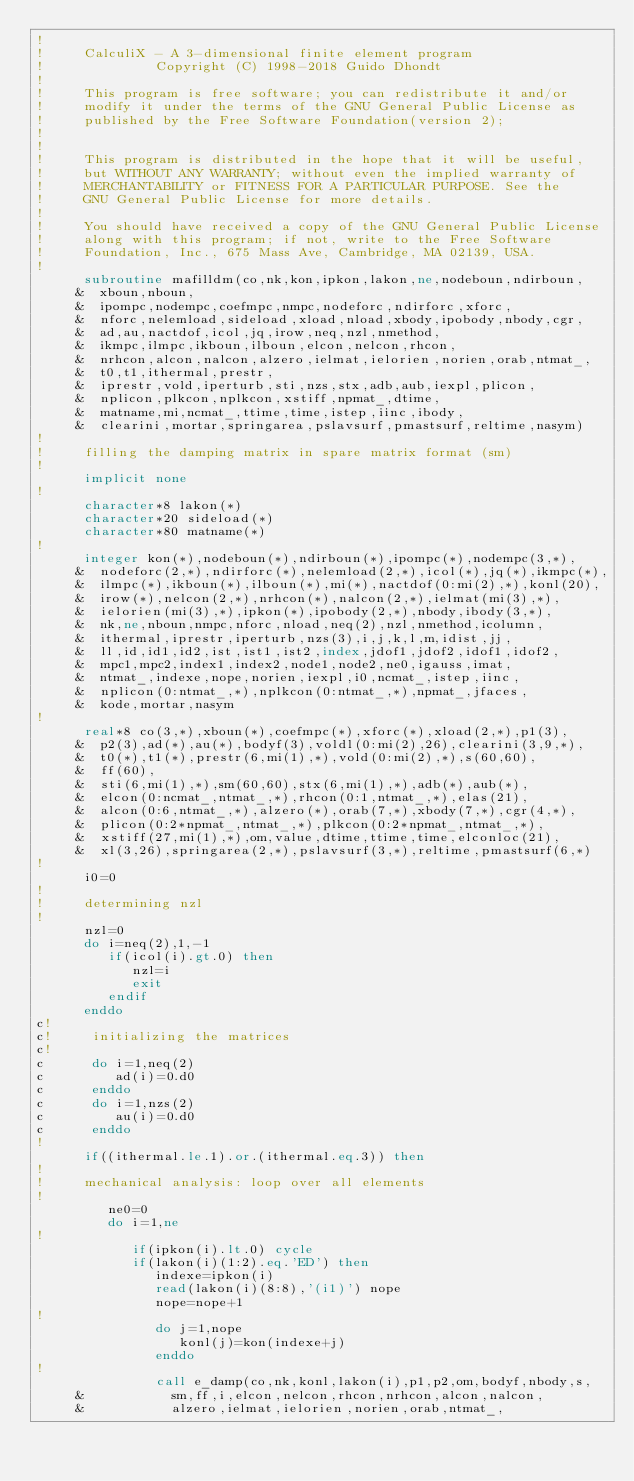<code> <loc_0><loc_0><loc_500><loc_500><_FORTRAN_>!
!     CalculiX - A 3-dimensional finite element program
!              Copyright (C) 1998-2018 Guido Dhondt
!
!     This program is free software; you can redistribute it and/or
!     modify it under the terms of the GNU General Public License as
!     published by the Free Software Foundation(version 2);
!     
!
!     This program is distributed in the hope that it will be useful,
!     but WITHOUT ANY WARRANTY; without even the implied warranty of 
!     MERCHANTABILITY or FITNESS FOR A PARTICULAR PURPOSE. See the 
!     GNU General Public License for more details.
!
!     You should have received a copy of the GNU General Public License
!     along with this program; if not, write to the Free Software
!     Foundation, Inc., 675 Mass Ave, Cambridge, MA 02139, USA.
!
      subroutine mafilldm(co,nk,kon,ipkon,lakon,ne,nodeboun,ndirboun,
     &  xboun,nboun,
     &  ipompc,nodempc,coefmpc,nmpc,nodeforc,ndirforc,xforc,
     &  nforc,nelemload,sideload,xload,nload,xbody,ipobody,nbody,cgr,
     &  ad,au,nactdof,icol,jq,irow,neq,nzl,nmethod,
     &  ikmpc,ilmpc,ikboun,ilboun,elcon,nelcon,rhcon,
     &  nrhcon,alcon,nalcon,alzero,ielmat,ielorien,norien,orab,ntmat_,
     &  t0,t1,ithermal,prestr,
     &  iprestr,vold,iperturb,sti,nzs,stx,adb,aub,iexpl,plicon,
     &  nplicon,plkcon,nplkcon,xstiff,npmat_,dtime,
     &  matname,mi,ncmat_,ttime,time,istep,iinc,ibody,
     &  clearini,mortar,springarea,pslavsurf,pmastsurf,reltime,nasym)
!
!     filling the damping matrix in spare matrix format (sm)
!
      implicit none
!
      character*8 lakon(*)
      character*20 sideload(*)
      character*80 matname(*)
!
      integer kon(*),nodeboun(*),ndirboun(*),ipompc(*),nodempc(3,*),
     &  nodeforc(2,*),ndirforc(*),nelemload(2,*),icol(*),jq(*),ikmpc(*),
     &  ilmpc(*),ikboun(*),ilboun(*),mi(*),nactdof(0:mi(2),*),konl(20),
     &  irow(*),nelcon(2,*),nrhcon(*),nalcon(2,*),ielmat(mi(3),*),
     &  ielorien(mi(3),*),ipkon(*),ipobody(2,*),nbody,ibody(3,*),
     &  nk,ne,nboun,nmpc,nforc,nload,neq(2),nzl,nmethod,icolumn,
     &  ithermal,iprestr,iperturb,nzs(3),i,j,k,l,m,idist,jj,
     &  ll,id,id1,id2,ist,ist1,ist2,index,jdof1,jdof2,idof1,idof2,
     &  mpc1,mpc2,index1,index2,node1,node2,ne0,igauss,imat,
     &  ntmat_,indexe,nope,norien,iexpl,i0,ncmat_,istep,iinc,
     &  nplicon(0:ntmat_,*),nplkcon(0:ntmat_,*),npmat_,jfaces,
     &  kode,mortar,nasym
!
      real*8 co(3,*),xboun(*),coefmpc(*),xforc(*),xload(2,*),p1(3),
     &  p2(3),ad(*),au(*),bodyf(3),voldl(0:mi(2),26),clearini(3,9,*),
     &  t0(*),t1(*),prestr(6,mi(1),*),vold(0:mi(2),*),s(60,60),
     &  ff(60),
     &  sti(6,mi(1),*),sm(60,60),stx(6,mi(1),*),adb(*),aub(*),
     &  elcon(0:ncmat_,ntmat_,*),rhcon(0:1,ntmat_,*),elas(21),
     &  alcon(0:6,ntmat_,*),alzero(*),orab(7,*),xbody(7,*),cgr(4,*),
     &  plicon(0:2*npmat_,ntmat_,*),plkcon(0:2*npmat_,ntmat_,*),
     &  xstiff(27,mi(1),*),om,value,dtime,ttime,time,elconloc(21),
     &  xl(3,26),springarea(2,*),pslavsurf(3,*),reltime,pmastsurf(6,*)
!
      i0=0
!
!     determining nzl
!
      nzl=0
      do i=neq(2),1,-1
         if(icol(i).gt.0) then
            nzl=i
            exit
         endif
      enddo
c!
c!     initializing the matrices
c!
c      do i=1,neq(2)
c         ad(i)=0.d0
c      enddo
c      do i=1,nzs(2)
c         au(i)=0.d0
c      enddo
!
      if((ithermal.le.1).or.(ithermal.eq.3)) then
!     
!     mechanical analysis: loop over all elements
!     
         ne0=0
         do i=1,ne
!     
            if(ipkon(i).lt.0) cycle
            if(lakon(i)(1:2).eq.'ED') then
               indexe=ipkon(i)
               read(lakon(i)(8:8),'(i1)') nope
               nope=nope+1
!     
               do j=1,nope
                  konl(j)=kon(indexe+j) 
               enddo
!     
               call e_damp(co,nk,konl,lakon(i),p1,p2,om,bodyf,nbody,s,
     &           sm,ff,i,elcon,nelcon,rhcon,nrhcon,alcon,nalcon,
     &           alzero,ielmat,ielorien,norien,orab,ntmat_,</code> 